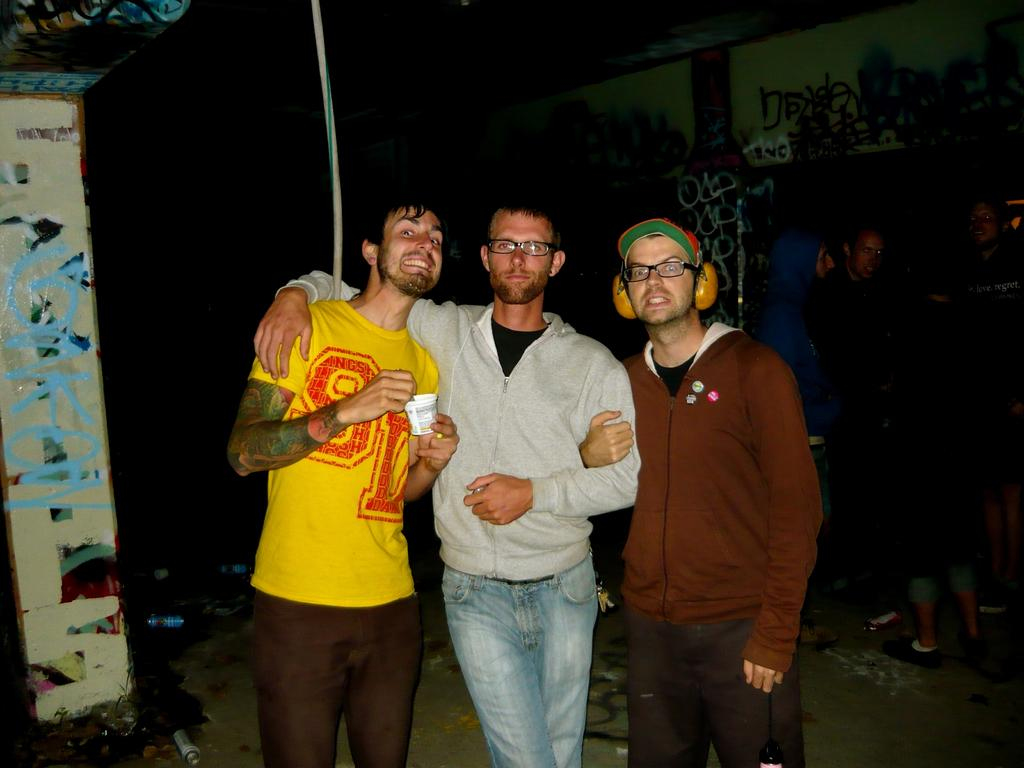How many people are present in the image? There are three people standing in the image. What can be seen behind the people in the image? There is a wall in the image. What is the color or lighting condition of the background in the image? The backdrop of the image is dark. What type of cabbage is being served on the table in the image? There is no table or cabbage present in the image. Where is the spot on the floor that needs to be cleaned in the image? There is no spot on the floor that needs to be cleaned in the image. 